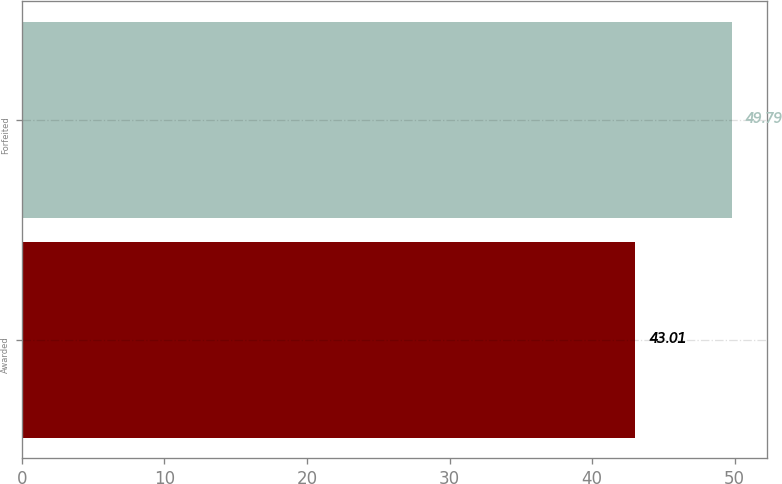<chart> <loc_0><loc_0><loc_500><loc_500><bar_chart><fcel>Awarded<fcel>Forfeited<nl><fcel>43.01<fcel>49.79<nl></chart> 